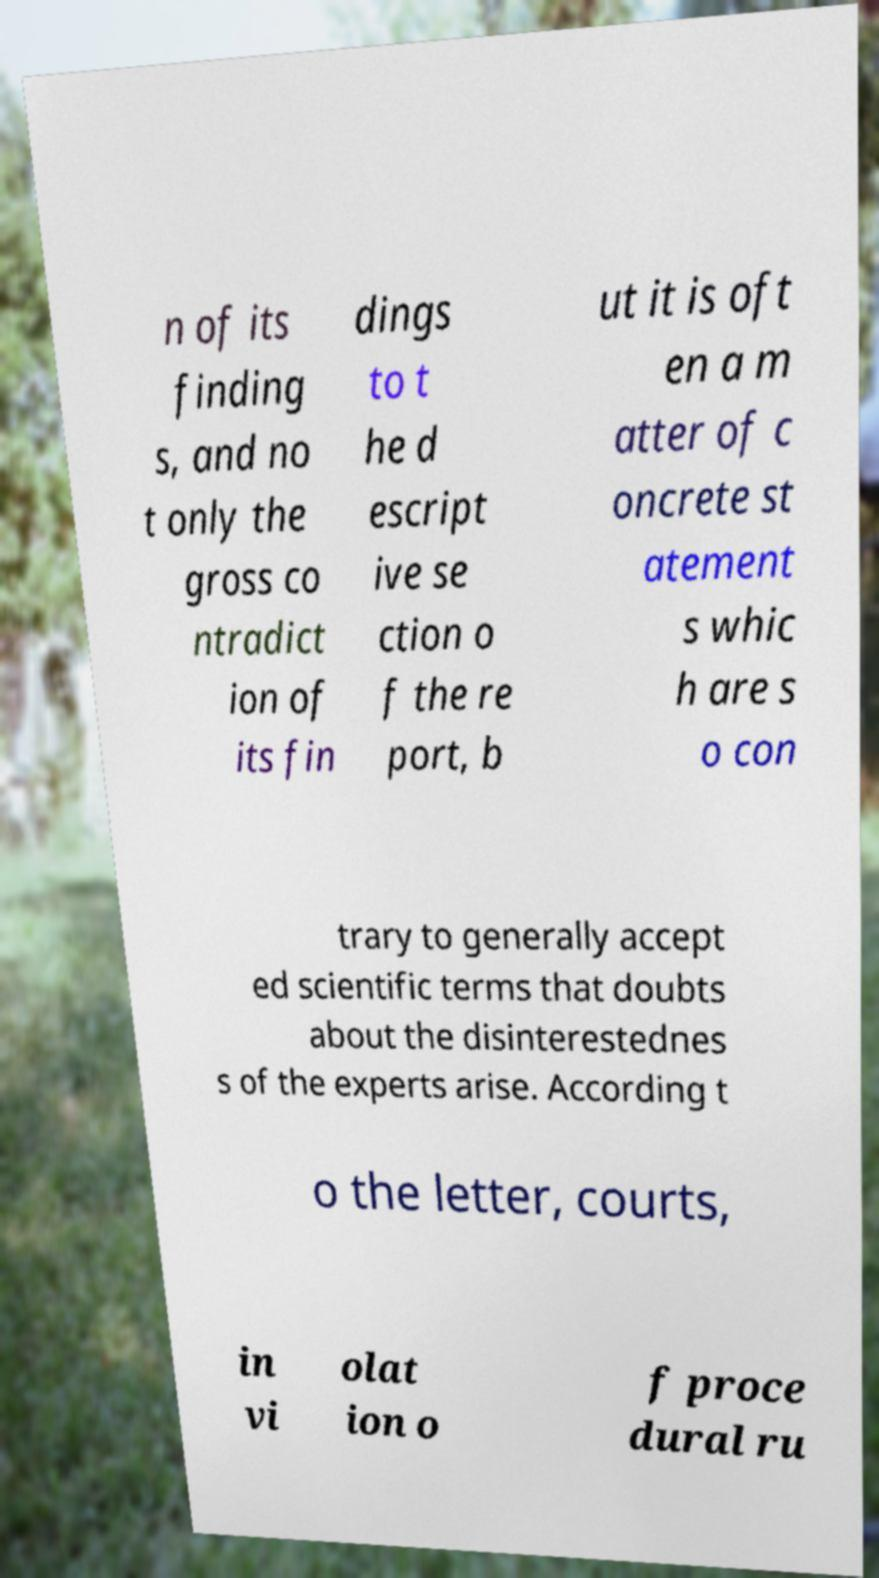Please identify and transcribe the text found in this image. n of its finding s, and no t only the gross co ntradict ion of its fin dings to t he d escript ive se ction o f the re port, b ut it is oft en a m atter of c oncrete st atement s whic h are s o con trary to generally accept ed scientific terms that doubts about the disinterestednes s of the experts arise. According t o the letter, courts, in vi olat ion o f proce dural ru 